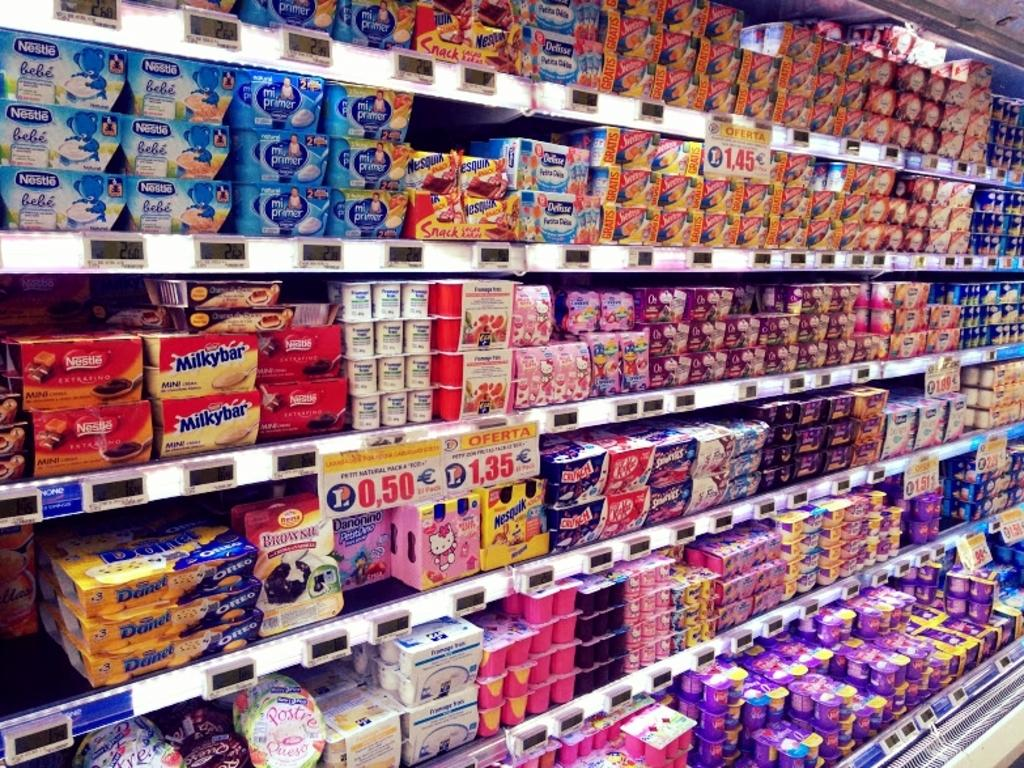What type of items can be found in the racks in the image? There are edible items present in the racks. How can customers determine the prices of the items in the racks? Price boards are present in the front of the racks to display the prices. What surprises are hidden behind the calendar in the image? There is no calendar present in the image, and therefore no surprises can be found behind it. 